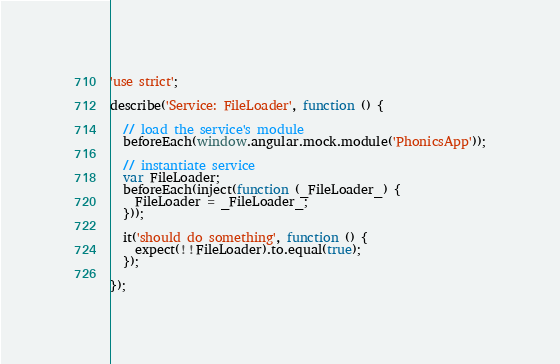Convert code to text. <code><loc_0><loc_0><loc_500><loc_500><_JavaScript_>'use strict';

describe('Service: FileLoader', function () {

  // load the service's module
  beforeEach(window.angular.mock.module('PhonicsApp'));

  // instantiate service
  var FileLoader;
  beforeEach(inject(function (_FileLoader_) {
    FileLoader = _FileLoader_;
  }));

  it('should do something', function () {
    expect(!!FileLoader).to.equal(true);
  });

});
</code> 